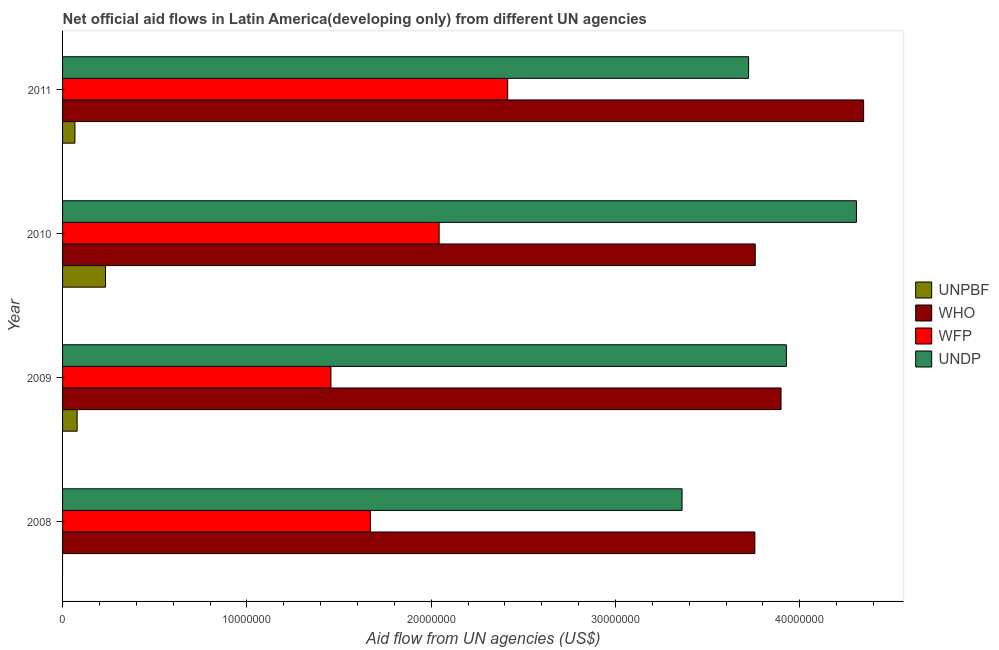How many different coloured bars are there?
Your answer should be compact. 4. Are the number of bars per tick equal to the number of legend labels?
Give a very brief answer. No. How many bars are there on the 4th tick from the top?
Offer a very short reply. 3. How many bars are there on the 4th tick from the bottom?
Offer a terse response. 4. What is the label of the 2nd group of bars from the top?
Provide a succinct answer. 2010. What is the amount of aid given by who in 2010?
Keep it short and to the point. 3.76e+07. Across all years, what is the maximum amount of aid given by who?
Offer a very short reply. 4.35e+07. Across all years, what is the minimum amount of aid given by wfp?
Make the answer very short. 1.46e+07. In which year was the amount of aid given by undp maximum?
Give a very brief answer. 2010. What is the total amount of aid given by unpbf in the graph?
Keep it short and to the point. 3.79e+06. What is the difference between the amount of aid given by who in 2008 and that in 2011?
Provide a succinct answer. -5.90e+06. What is the difference between the amount of aid given by who in 2009 and the amount of aid given by unpbf in 2010?
Provide a short and direct response. 3.66e+07. What is the average amount of aid given by wfp per year?
Give a very brief answer. 1.90e+07. In the year 2008, what is the difference between the amount of aid given by undp and amount of aid given by who?
Ensure brevity in your answer.  -3.95e+06. In how many years, is the amount of aid given by undp greater than 18000000 US$?
Give a very brief answer. 4. What is the ratio of the amount of aid given by undp in 2009 to that in 2010?
Provide a succinct answer. 0.91. Is the amount of aid given by wfp in 2008 less than that in 2011?
Your answer should be compact. Yes. Is the difference between the amount of aid given by undp in 2009 and 2010 greater than the difference between the amount of aid given by wfp in 2009 and 2010?
Your answer should be compact. Yes. What is the difference between the highest and the second highest amount of aid given by undp?
Provide a succinct answer. 3.80e+06. What is the difference between the highest and the lowest amount of aid given by wfp?
Make the answer very short. 9.59e+06. In how many years, is the amount of aid given by undp greater than the average amount of aid given by undp taken over all years?
Your response must be concise. 2. How many bars are there?
Offer a very short reply. 15. Are all the bars in the graph horizontal?
Provide a short and direct response. Yes. Where does the legend appear in the graph?
Offer a very short reply. Center right. How many legend labels are there?
Your answer should be compact. 4. What is the title of the graph?
Offer a terse response. Net official aid flows in Latin America(developing only) from different UN agencies. What is the label or title of the X-axis?
Offer a very short reply. Aid flow from UN agencies (US$). What is the Aid flow from UN agencies (US$) of UNPBF in 2008?
Give a very brief answer. 0. What is the Aid flow from UN agencies (US$) in WHO in 2008?
Keep it short and to the point. 3.76e+07. What is the Aid flow from UN agencies (US$) of WFP in 2008?
Your answer should be compact. 1.67e+07. What is the Aid flow from UN agencies (US$) of UNDP in 2008?
Make the answer very short. 3.36e+07. What is the Aid flow from UN agencies (US$) in UNPBF in 2009?
Your answer should be compact. 7.90e+05. What is the Aid flow from UN agencies (US$) in WHO in 2009?
Your answer should be compact. 3.90e+07. What is the Aid flow from UN agencies (US$) in WFP in 2009?
Make the answer very short. 1.46e+07. What is the Aid flow from UN agencies (US$) in UNDP in 2009?
Offer a terse response. 3.93e+07. What is the Aid flow from UN agencies (US$) in UNPBF in 2010?
Make the answer very short. 2.33e+06. What is the Aid flow from UN agencies (US$) in WHO in 2010?
Keep it short and to the point. 3.76e+07. What is the Aid flow from UN agencies (US$) of WFP in 2010?
Offer a very short reply. 2.04e+07. What is the Aid flow from UN agencies (US$) in UNDP in 2010?
Your answer should be compact. 4.31e+07. What is the Aid flow from UN agencies (US$) in UNPBF in 2011?
Give a very brief answer. 6.70e+05. What is the Aid flow from UN agencies (US$) in WHO in 2011?
Make the answer very short. 4.35e+07. What is the Aid flow from UN agencies (US$) in WFP in 2011?
Give a very brief answer. 2.42e+07. What is the Aid flow from UN agencies (US$) in UNDP in 2011?
Offer a terse response. 3.72e+07. Across all years, what is the maximum Aid flow from UN agencies (US$) of UNPBF?
Your answer should be very brief. 2.33e+06. Across all years, what is the maximum Aid flow from UN agencies (US$) of WHO?
Offer a very short reply. 4.35e+07. Across all years, what is the maximum Aid flow from UN agencies (US$) in WFP?
Provide a succinct answer. 2.42e+07. Across all years, what is the maximum Aid flow from UN agencies (US$) in UNDP?
Ensure brevity in your answer.  4.31e+07. Across all years, what is the minimum Aid flow from UN agencies (US$) in UNPBF?
Keep it short and to the point. 0. Across all years, what is the minimum Aid flow from UN agencies (US$) of WHO?
Offer a very short reply. 3.76e+07. Across all years, what is the minimum Aid flow from UN agencies (US$) of WFP?
Your answer should be compact. 1.46e+07. Across all years, what is the minimum Aid flow from UN agencies (US$) in UNDP?
Offer a very short reply. 3.36e+07. What is the total Aid flow from UN agencies (US$) of UNPBF in the graph?
Provide a short and direct response. 3.79e+06. What is the total Aid flow from UN agencies (US$) of WHO in the graph?
Your answer should be very brief. 1.58e+08. What is the total Aid flow from UN agencies (US$) of WFP in the graph?
Your answer should be compact. 7.58e+07. What is the total Aid flow from UN agencies (US$) of UNDP in the graph?
Make the answer very short. 1.53e+08. What is the difference between the Aid flow from UN agencies (US$) of WHO in 2008 and that in 2009?
Your answer should be compact. -1.42e+06. What is the difference between the Aid flow from UN agencies (US$) of WFP in 2008 and that in 2009?
Offer a terse response. 2.14e+06. What is the difference between the Aid flow from UN agencies (US$) of UNDP in 2008 and that in 2009?
Your answer should be compact. -5.66e+06. What is the difference between the Aid flow from UN agencies (US$) of WFP in 2008 and that in 2010?
Your answer should be compact. -3.73e+06. What is the difference between the Aid flow from UN agencies (US$) of UNDP in 2008 and that in 2010?
Give a very brief answer. -9.46e+06. What is the difference between the Aid flow from UN agencies (US$) in WHO in 2008 and that in 2011?
Provide a short and direct response. -5.90e+06. What is the difference between the Aid flow from UN agencies (US$) in WFP in 2008 and that in 2011?
Keep it short and to the point. -7.45e+06. What is the difference between the Aid flow from UN agencies (US$) of UNDP in 2008 and that in 2011?
Ensure brevity in your answer.  -3.61e+06. What is the difference between the Aid flow from UN agencies (US$) in UNPBF in 2009 and that in 2010?
Keep it short and to the point. -1.54e+06. What is the difference between the Aid flow from UN agencies (US$) of WHO in 2009 and that in 2010?
Give a very brief answer. 1.40e+06. What is the difference between the Aid flow from UN agencies (US$) of WFP in 2009 and that in 2010?
Your answer should be very brief. -5.87e+06. What is the difference between the Aid flow from UN agencies (US$) in UNDP in 2009 and that in 2010?
Your answer should be very brief. -3.80e+06. What is the difference between the Aid flow from UN agencies (US$) in UNPBF in 2009 and that in 2011?
Give a very brief answer. 1.20e+05. What is the difference between the Aid flow from UN agencies (US$) of WHO in 2009 and that in 2011?
Your response must be concise. -4.48e+06. What is the difference between the Aid flow from UN agencies (US$) in WFP in 2009 and that in 2011?
Your answer should be very brief. -9.59e+06. What is the difference between the Aid flow from UN agencies (US$) in UNDP in 2009 and that in 2011?
Keep it short and to the point. 2.05e+06. What is the difference between the Aid flow from UN agencies (US$) in UNPBF in 2010 and that in 2011?
Give a very brief answer. 1.66e+06. What is the difference between the Aid flow from UN agencies (US$) of WHO in 2010 and that in 2011?
Offer a terse response. -5.88e+06. What is the difference between the Aid flow from UN agencies (US$) of WFP in 2010 and that in 2011?
Offer a terse response. -3.72e+06. What is the difference between the Aid flow from UN agencies (US$) of UNDP in 2010 and that in 2011?
Make the answer very short. 5.85e+06. What is the difference between the Aid flow from UN agencies (US$) in WHO in 2008 and the Aid flow from UN agencies (US$) in WFP in 2009?
Provide a succinct answer. 2.30e+07. What is the difference between the Aid flow from UN agencies (US$) in WHO in 2008 and the Aid flow from UN agencies (US$) in UNDP in 2009?
Your answer should be compact. -1.71e+06. What is the difference between the Aid flow from UN agencies (US$) in WFP in 2008 and the Aid flow from UN agencies (US$) in UNDP in 2009?
Your answer should be compact. -2.26e+07. What is the difference between the Aid flow from UN agencies (US$) of WHO in 2008 and the Aid flow from UN agencies (US$) of WFP in 2010?
Your answer should be very brief. 1.71e+07. What is the difference between the Aid flow from UN agencies (US$) in WHO in 2008 and the Aid flow from UN agencies (US$) in UNDP in 2010?
Your response must be concise. -5.51e+06. What is the difference between the Aid flow from UN agencies (US$) in WFP in 2008 and the Aid flow from UN agencies (US$) in UNDP in 2010?
Offer a very short reply. -2.64e+07. What is the difference between the Aid flow from UN agencies (US$) of WHO in 2008 and the Aid flow from UN agencies (US$) of WFP in 2011?
Your response must be concise. 1.34e+07. What is the difference between the Aid flow from UN agencies (US$) of WHO in 2008 and the Aid flow from UN agencies (US$) of UNDP in 2011?
Offer a very short reply. 3.40e+05. What is the difference between the Aid flow from UN agencies (US$) in WFP in 2008 and the Aid flow from UN agencies (US$) in UNDP in 2011?
Offer a terse response. -2.05e+07. What is the difference between the Aid flow from UN agencies (US$) of UNPBF in 2009 and the Aid flow from UN agencies (US$) of WHO in 2010?
Make the answer very short. -3.68e+07. What is the difference between the Aid flow from UN agencies (US$) in UNPBF in 2009 and the Aid flow from UN agencies (US$) in WFP in 2010?
Provide a succinct answer. -1.96e+07. What is the difference between the Aid flow from UN agencies (US$) in UNPBF in 2009 and the Aid flow from UN agencies (US$) in UNDP in 2010?
Offer a very short reply. -4.23e+07. What is the difference between the Aid flow from UN agencies (US$) of WHO in 2009 and the Aid flow from UN agencies (US$) of WFP in 2010?
Provide a succinct answer. 1.86e+07. What is the difference between the Aid flow from UN agencies (US$) of WHO in 2009 and the Aid flow from UN agencies (US$) of UNDP in 2010?
Offer a very short reply. -4.09e+06. What is the difference between the Aid flow from UN agencies (US$) of WFP in 2009 and the Aid flow from UN agencies (US$) of UNDP in 2010?
Give a very brief answer. -2.85e+07. What is the difference between the Aid flow from UN agencies (US$) of UNPBF in 2009 and the Aid flow from UN agencies (US$) of WHO in 2011?
Provide a succinct answer. -4.27e+07. What is the difference between the Aid flow from UN agencies (US$) of UNPBF in 2009 and the Aid flow from UN agencies (US$) of WFP in 2011?
Your answer should be compact. -2.34e+07. What is the difference between the Aid flow from UN agencies (US$) of UNPBF in 2009 and the Aid flow from UN agencies (US$) of UNDP in 2011?
Provide a short and direct response. -3.64e+07. What is the difference between the Aid flow from UN agencies (US$) of WHO in 2009 and the Aid flow from UN agencies (US$) of WFP in 2011?
Your answer should be very brief. 1.48e+07. What is the difference between the Aid flow from UN agencies (US$) of WHO in 2009 and the Aid flow from UN agencies (US$) of UNDP in 2011?
Offer a terse response. 1.76e+06. What is the difference between the Aid flow from UN agencies (US$) in WFP in 2009 and the Aid flow from UN agencies (US$) in UNDP in 2011?
Ensure brevity in your answer.  -2.27e+07. What is the difference between the Aid flow from UN agencies (US$) of UNPBF in 2010 and the Aid flow from UN agencies (US$) of WHO in 2011?
Offer a terse response. -4.11e+07. What is the difference between the Aid flow from UN agencies (US$) in UNPBF in 2010 and the Aid flow from UN agencies (US$) in WFP in 2011?
Make the answer very short. -2.18e+07. What is the difference between the Aid flow from UN agencies (US$) of UNPBF in 2010 and the Aid flow from UN agencies (US$) of UNDP in 2011?
Your answer should be very brief. -3.49e+07. What is the difference between the Aid flow from UN agencies (US$) of WHO in 2010 and the Aid flow from UN agencies (US$) of WFP in 2011?
Provide a short and direct response. 1.34e+07. What is the difference between the Aid flow from UN agencies (US$) in WFP in 2010 and the Aid flow from UN agencies (US$) in UNDP in 2011?
Offer a very short reply. -1.68e+07. What is the average Aid flow from UN agencies (US$) in UNPBF per year?
Provide a succinct answer. 9.48e+05. What is the average Aid flow from UN agencies (US$) of WHO per year?
Give a very brief answer. 3.94e+07. What is the average Aid flow from UN agencies (US$) in WFP per year?
Offer a terse response. 1.90e+07. What is the average Aid flow from UN agencies (US$) in UNDP per year?
Give a very brief answer. 3.83e+07. In the year 2008, what is the difference between the Aid flow from UN agencies (US$) in WHO and Aid flow from UN agencies (US$) in WFP?
Keep it short and to the point. 2.09e+07. In the year 2008, what is the difference between the Aid flow from UN agencies (US$) in WHO and Aid flow from UN agencies (US$) in UNDP?
Offer a very short reply. 3.95e+06. In the year 2008, what is the difference between the Aid flow from UN agencies (US$) of WFP and Aid flow from UN agencies (US$) of UNDP?
Your answer should be compact. -1.69e+07. In the year 2009, what is the difference between the Aid flow from UN agencies (US$) in UNPBF and Aid flow from UN agencies (US$) in WHO?
Provide a short and direct response. -3.82e+07. In the year 2009, what is the difference between the Aid flow from UN agencies (US$) in UNPBF and Aid flow from UN agencies (US$) in WFP?
Offer a terse response. -1.38e+07. In the year 2009, what is the difference between the Aid flow from UN agencies (US$) of UNPBF and Aid flow from UN agencies (US$) of UNDP?
Your response must be concise. -3.85e+07. In the year 2009, what is the difference between the Aid flow from UN agencies (US$) of WHO and Aid flow from UN agencies (US$) of WFP?
Provide a short and direct response. 2.44e+07. In the year 2009, what is the difference between the Aid flow from UN agencies (US$) of WFP and Aid flow from UN agencies (US$) of UNDP?
Your answer should be very brief. -2.47e+07. In the year 2010, what is the difference between the Aid flow from UN agencies (US$) of UNPBF and Aid flow from UN agencies (US$) of WHO?
Offer a terse response. -3.52e+07. In the year 2010, what is the difference between the Aid flow from UN agencies (US$) of UNPBF and Aid flow from UN agencies (US$) of WFP?
Your response must be concise. -1.81e+07. In the year 2010, what is the difference between the Aid flow from UN agencies (US$) in UNPBF and Aid flow from UN agencies (US$) in UNDP?
Ensure brevity in your answer.  -4.07e+07. In the year 2010, what is the difference between the Aid flow from UN agencies (US$) in WHO and Aid flow from UN agencies (US$) in WFP?
Provide a short and direct response. 1.72e+07. In the year 2010, what is the difference between the Aid flow from UN agencies (US$) in WHO and Aid flow from UN agencies (US$) in UNDP?
Your response must be concise. -5.49e+06. In the year 2010, what is the difference between the Aid flow from UN agencies (US$) of WFP and Aid flow from UN agencies (US$) of UNDP?
Your answer should be very brief. -2.26e+07. In the year 2011, what is the difference between the Aid flow from UN agencies (US$) of UNPBF and Aid flow from UN agencies (US$) of WHO?
Provide a succinct answer. -4.28e+07. In the year 2011, what is the difference between the Aid flow from UN agencies (US$) in UNPBF and Aid flow from UN agencies (US$) in WFP?
Offer a very short reply. -2.35e+07. In the year 2011, what is the difference between the Aid flow from UN agencies (US$) in UNPBF and Aid flow from UN agencies (US$) in UNDP?
Provide a succinct answer. -3.66e+07. In the year 2011, what is the difference between the Aid flow from UN agencies (US$) in WHO and Aid flow from UN agencies (US$) in WFP?
Offer a terse response. 1.93e+07. In the year 2011, what is the difference between the Aid flow from UN agencies (US$) of WHO and Aid flow from UN agencies (US$) of UNDP?
Your response must be concise. 6.24e+06. In the year 2011, what is the difference between the Aid flow from UN agencies (US$) in WFP and Aid flow from UN agencies (US$) in UNDP?
Your answer should be compact. -1.31e+07. What is the ratio of the Aid flow from UN agencies (US$) in WHO in 2008 to that in 2009?
Provide a short and direct response. 0.96. What is the ratio of the Aid flow from UN agencies (US$) of WFP in 2008 to that in 2009?
Your answer should be compact. 1.15. What is the ratio of the Aid flow from UN agencies (US$) of UNDP in 2008 to that in 2009?
Your response must be concise. 0.86. What is the ratio of the Aid flow from UN agencies (US$) of WHO in 2008 to that in 2010?
Provide a succinct answer. 1. What is the ratio of the Aid flow from UN agencies (US$) in WFP in 2008 to that in 2010?
Provide a short and direct response. 0.82. What is the ratio of the Aid flow from UN agencies (US$) of UNDP in 2008 to that in 2010?
Your answer should be compact. 0.78. What is the ratio of the Aid flow from UN agencies (US$) in WHO in 2008 to that in 2011?
Your answer should be very brief. 0.86. What is the ratio of the Aid flow from UN agencies (US$) in WFP in 2008 to that in 2011?
Provide a succinct answer. 0.69. What is the ratio of the Aid flow from UN agencies (US$) of UNDP in 2008 to that in 2011?
Provide a succinct answer. 0.9. What is the ratio of the Aid flow from UN agencies (US$) in UNPBF in 2009 to that in 2010?
Provide a succinct answer. 0.34. What is the ratio of the Aid flow from UN agencies (US$) of WHO in 2009 to that in 2010?
Offer a very short reply. 1.04. What is the ratio of the Aid flow from UN agencies (US$) in WFP in 2009 to that in 2010?
Make the answer very short. 0.71. What is the ratio of the Aid flow from UN agencies (US$) of UNDP in 2009 to that in 2010?
Your response must be concise. 0.91. What is the ratio of the Aid flow from UN agencies (US$) in UNPBF in 2009 to that in 2011?
Provide a succinct answer. 1.18. What is the ratio of the Aid flow from UN agencies (US$) in WHO in 2009 to that in 2011?
Provide a succinct answer. 0.9. What is the ratio of the Aid flow from UN agencies (US$) in WFP in 2009 to that in 2011?
Ensure brevity in your answer.  0.6. What is the ratio of the Aid flow from UN agencies (US$) of UNDP in 2009 to that in 2011?
Provide a succinct answer. 1.06. What is the ratio of the Aid flow from UN agencies (US$) in UNPBF in 2010 to that in 2011?
Offer a terse response. 3.48. What is the ratio of the Aid flow from UN agencies (US$) in WHO in 2010 to that in 2011?
Keep it short and to the point. 0.86. What is the ratio of the Aid flow from UN agencies (US$) of WFP in 2010 to that in 2011?
Your answer should be compact. 0.85. What is the ratio of the Aid flow from UN agencies (US$) of UNDP in 2010 to that in 2011?
Your answer should be compact. 1.16. What is the difference between the highest and the second highest Aid flow from UN agencies (US$) of UNPBF?
Ensure brevity in your answer.  1.54e+06. What is the difference between the highest and the second highest Aid flow from UN agencies (US$) in WHO?
Give a very brief answer. 4.48e+06. What is the difference between the highest and the second highest Aid flow from UN agencies (US$) of WFP?
Provide a succinct answer. 3.72e+06. What is the difference between the highest and the second highest Aid flow from UN agencies (US$) in UNDP?
Your answer should be very brief. 3.80e+06. What is the difference between the highest and the lowest Aid flow from UN agencies (US$) of UNPBF?
Ensure brevity in your answer.  2.33e+06. What is the difference between the highest and the lowest Aid flow from UN agencies (US$) in WHO?
Your answer should be very brief. 5.90e+06. What is the difference between the highest and the lowest Aid flow from UN agencies (US$) in WFP?
Provide a short and direct response. 9.59e+06. What is the difference between the highest and the lowest Aid flow from UN agencies (US$) of UNDP?
Your response must be concise. 9.46e+06. 